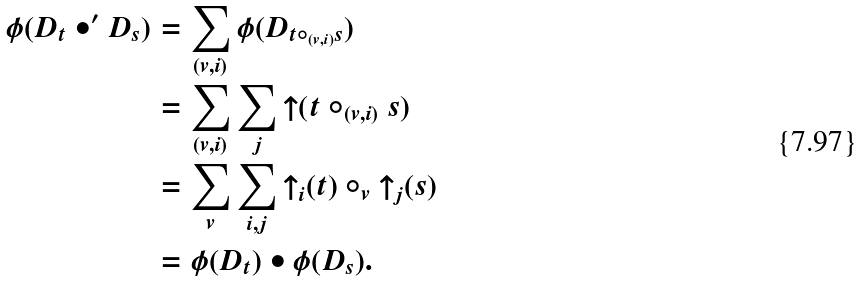Convert formula to latex. <formula><loc_0><loc_0><loc_500><loc_500>\phi ( D _ { t } \bullet ^ { \prime } D _ { s } ) & = \sum _ { ( v , i ) } \phi ( D _ { t \circ _ { ( v , i ) } s } ) \\ & = \sum _ { ( v , i ) } \sum _ { j } { \uparrow } ( t \circ _ { ( v , i ) } s ) \\ & = \sum _ { v } \sum _ { i , j } { \uparrow } _ { i } ( t ) \circ _ { v } { \uparrow } _ { j } ( s ) \\ & = \phi ( D _ { t } ) \bullet \phi ( D _ { s } ) .</formula> 